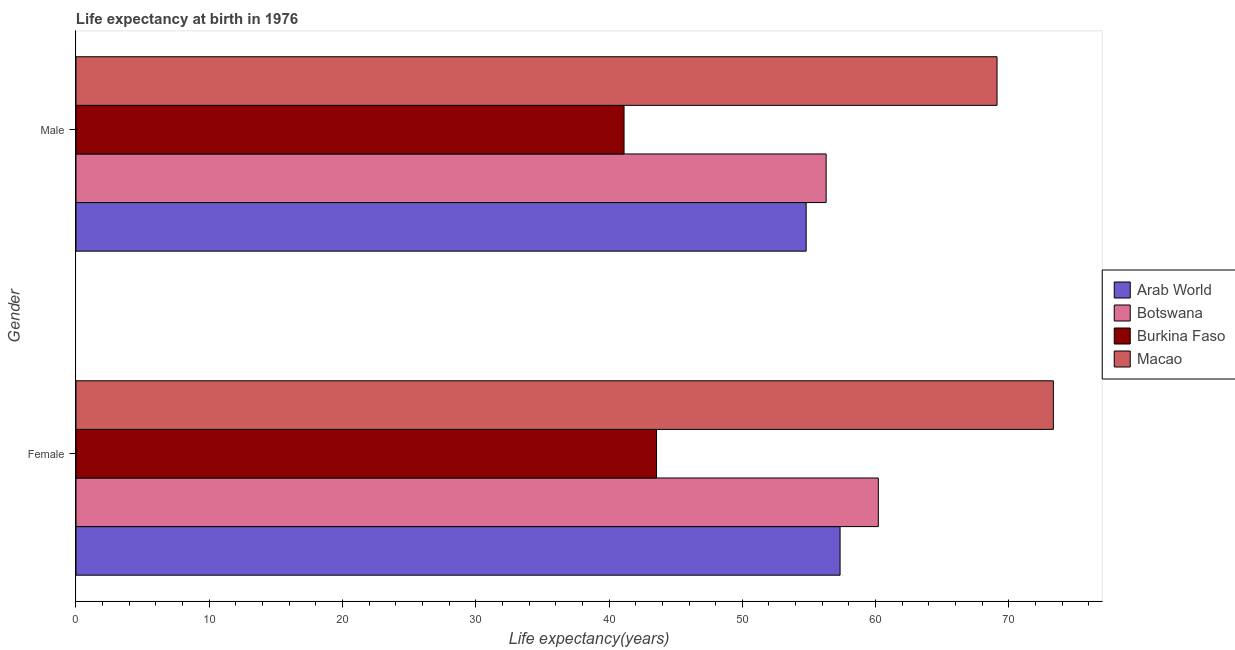How many different coloured bars are there?
Your response must be concise. 4. How many groups of bars are there?
Your answer should be compact. 2. Are the number of bars per tick equal to the number of legend labels?
Provide a succinct answer. Yes. Are the number of bars on each tick of the Y-axis equal?
Offer a terse response. Yes. How many bars are there on the 1st tick from the bottom?
Provide a short and direct response. 4. What is the life expectancy(female) in Macao?
Offer a very short reply. 73.34. Across all countries, what is the maximum life expectancy(female)?
Make the answer very short. 73.34. Across all countries, what is the minimum life expectancy(female)?
Give a very brief answer. 43.56. In which country was the life expectancy(female) maximum?
Give a very brief answer. Macao. In which country was the life expectancy(male) minimum?
Provide a succinct answer. Burkina Faso. What is the total life expectancy(male) in the graph?
Provide a short and direct response. 221.32. What is the difference between the life expectancy(male) in Botswana and that in Macao?
Ensure brevity in your answer.  -12.82. What is the difference between the life expectancy(female) in Botswana and the life expectancy(male) in Burkina Faso?
Offer a very short reply. 19.08. What is the average life expectancy(female) per country?
Make the answer very short. 58.61. What is the difference between the life expectancy(male) and life expectancy(female) in Burkina Faso?
Offer a very short reply. -2.44. What is the ratio of the life expectancy(female) in Arab World to that in Botswana?
Your answer should be very brief. 0.95. In how many countries, is the life expectancy(female) greater than the average life expectancy(female) taken over all countries?
Make the answer very short. 2. What does the 1st bar from the top in Male represents?
Provide a succinct answer. Macao. What does the 2nd bar from the bottom in Male represents?
Give a very brief answer. Botswana. How many bars are there?
Provide a succinct answer. 8. Are all the bars in the graph horizontal?
Keep it short and to the point. Yes. Are the values on the major ticks of X-axis written in scientific E-notation?
Ensure brevity in your answer.  No. What is the title of the graph?
Your answer should be very brief. Life expectancy at birth in 1976. What is the label or title of the X-axis?
Offer a terse response. Life expectancy(years). What is the Life expectancy(years) in Arab World in Female?
Keep it short and to the point. 57.34. What is the Life expectancy(years) of Botswana in Female?
Keep it short and to the point. 60.2. What is the Life expectancy(years) of Burkina Faso in Female?
Your answer should be very brief. 43.56. What is the Life expectancy(years) of Macao in Female?
Provide a short and direct response. 73.34. What is the Life expectancy(years) of Arab World in Male?
Make the answer very short. 54.79. What is the Life expectancy(years) of Botswana in Male?
Your response must be concise. 56.29. What is the Life expectancy(years) of Burkina Faso in Male?
Your response must be concise. 41.12. What is the Life expectancy(years) in Macao in Male?
Give a very brief answer. 69.11. Across all Gender, what is the maximum Life expectancy(years) in Arab World?
Offer a terse response. 57.34. Across all Gender, what is the maximum Life expectancy(years) in Botswana?
Provide a succinct answer. 60.2. Across all Gender, what is the maximum Life expectancy(years) of Burkina Faso?
Offer a very short reply. 43.56. Across all Gender, what is the maximum Life expectancy(years) of Macao?
Your response must be concise. 73.34. Across all Gender, what is the minimum Life expectancy(years) in Arab World?
Ensure brevity in your answer.  54.79. Across all Gender, what is the minimum Life expectancy(years) of Botswana?
Your response must be concise. 56.29. Across all Gender, what is the minimum Life expectancy(years) in Burkina Faso?
Offer a very short reply. 41.12. Across all Gender, what is the minimum Life expectancy(years) in Macao?
Make the answer very short. 69.11. What is the total Life expectancy(years) in Arab World in the graph?
Provide a succinct answer. 112.13. What is the total Life expectancy(years) in Botswana in the graph?
Ensure brevity in your answer.  116.49. What is the total Life expectancy(years) in Burkina Faso in the graph?
Make the answer very short. 84.69. What is the total Life expectancy(years) of Macao in the graph?
Give a very brief answer. 142.45. What is the difference between the Life expectancy(years) in Arab World in Female and that in Male?
Your response must be concise. 2.55. What is the difference between the Life expectancy(years) in Botswana in Female and that in Male?
Provide a succinct answer. 3.92. What is the difference between the Life expectancy(years) in Burkina Faso in Female and that in Male?
Provide a succinct answer. 2.44. What is the difference between the Life expectancy(years) in Macao in Female and that in Male?
Provide a short and direct response. 4.23. What is the difference between the Life expectancy(years) of Arab World in Female and the Life expectancy(years) of Botswana in Male?
Your response must be concise. 1.05. What is the difference between the Life expectancy(years) of Arab World in Female and the Life expectancy(years) of Burkina Faso in Male?
Make the answer very short. 16.21. What is the difference between the Life expectancy(years) of Arab World in Female and the Life expectancy(years) of Macao in Male?
Your answer should be compact. -11.78. What is the difference between the Life expectancy(years) of Botswana in Female and the Life expectancy(years) of Burkina Faso in Male?
Your response must be concise. 19.08. What is the difference between the Life expectancy(years) in Botswana in Female and the Life expectancy(years) in Macao in Male?
Make the answer very short. -8.91. What is the difference between the Life expectancy(years) in Burkina Faso in Female and the Life expectancy(years) in Macao in Male?
Provide a succinct answer. -25.55. What is the average Life expectancy(years) of Arab World per Gender?
Provide a short and direct response. 56.06. What is the average Life expectancy(years) of Botswana per Gender?
Your answer should be very brief. 58.25. What is the average Life expectancy(years) of Burkina Faso per Gender?
Your answer should be very brief. 42.34. What is the average Life expectancy(years) of Macao per Gender?
Your answer should be very brief. 71.23. What is the difference between the Life expectancy(years) in Arab World and Life expectancy(years) in Botswana in Female?
Make the answer very short. -2.87. What is the difference between the Life expectancy(years) in Arab World and Life expectancy(years) in Burkina Faso in Female?
Ensure brevity in your answer.  13.77. What is the difference between the Life expectancy(years) of Arab World and Life expectancy(years) of Macao in Female?
Keep it short and to the point. -16. What is the difference between the Life expectancy(years) in Botswana and Life expectancy(years) in Burkina Faso in Female?
Provide a short and direct response. 16.64. What is the difference between the Life expectancy(years) in Botswana and Life expectancy(years) in Macao in Female?
Keep it short and to the point. -13.13. What is the difference between the Life expectancy(years) in Burkina Faso and Life expectancy(years) in Macao in Female?
Provide a succinct answer. -29.78. What is the difference between the Life expectancy(years) in Arab World and Life expectancy(years) in Botswana in Male?
Your answer should be very brief. -1.5. What is the difference between the Life expectancy(years) of Arab World and Life expectancy(years) of Burkina Faso in Male?
Your answer should be compact. 13.66. What is the difference between the Life expectancy(years) in Arab World and Life expectancy(years) in Macao in Male?
Offer a very short reply. -14.32. What is the difference between the Life expectancy(years) in Botswana and Life expectancy(years) in Burkina Faso in Male?
Your answer should be compact. 15.16. What is the difference between the Life expectancy(years) of Botswana and Life expectancy(years) of Macao in Male?
Provide a short and direct response. -12.82. What is the difference between the Life expectancy(years) in Burkina Faso and Life expectancy(years) in Macao in Male?
Provide a succinct answer. -27.99. What is the ratio of the Life expectancy(years) of Arab World in Female to that in Male?
Keep it short and to the point. 1.05. What is the ratio of the Life expectancy(years) of Botswana in Female to that in Male?
Offer a terse response. 1.07. What is the ratio of the Life expectancy(years) in Burkina Faso in Female to that in Male?
Keep it short and to the point. 1.06. What is the ratio of the Life expectancy(years) in Macao in Female to that in Male?
Keep it short and to the point. 1.06. What is the difference between the highest and the second highest Life expectancy(years) in Arab World?
Keep it short and to the point. 2.55. What is the difference between the highest and the second highest Life expectancy(years) in Botswana?
Your answer should be compact. 3.92. What is the difference between the highest and the second highest Life expectancy(years) in Burkina Faso?
Offer a very short reply. 2.44. What is the difference between the highest and the second highest Life expectancy(years) in Macao?
Give a very brief answer. 4.23. What is the difference between the highest and the lowest Life expectancy(years) in Arab World?
Give a very brief answer. 2.55. What is the difference between the highest and the lowest Life expectancy(years) in Botswana?
Offer a terse response. 3.92. What is the difference between the highest and the lowest Life expectancy(years) of Burkina Faso?
Keep it short and to the point. 2.44. What is the difference between the highest and the lowest Life expectancy(years) of Macao?
Your response must be concise. 4.23. 